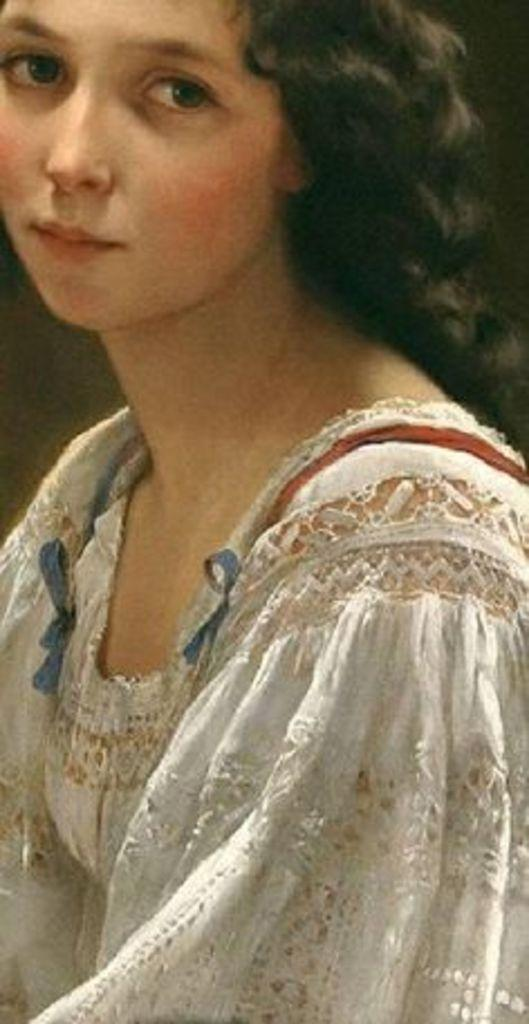Who is present in the image? There is a woman in the image. What type of linen is the woman using to cover her degree in the image? There is no linen or degree present in the image; it only features a woman. 